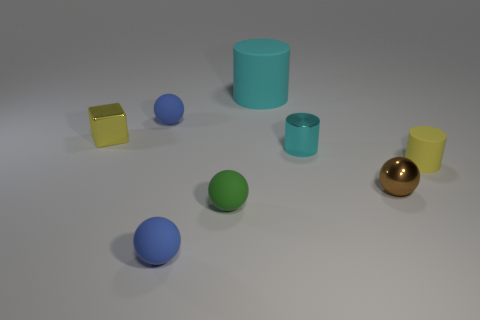There is a small sphere behind the yellow object left of the large thing; what color is it? blue 